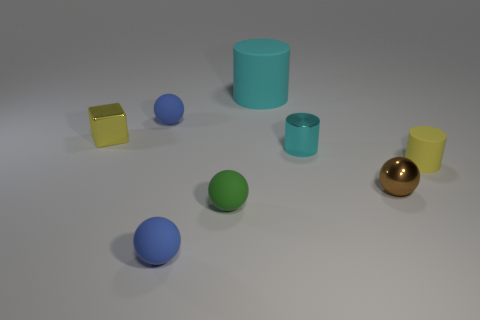There is a small sphere behind the yellow object left of the large thing; what color is it? blue 